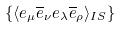<formula> <loc_0><loc_0><loc_500><loc_500>\{ \langle e _ { \mu } \overline { e } _ { \nu } e _ { \lambda } \overline { e } _ { \rho } \rangle _ { I S } \}</formula> 